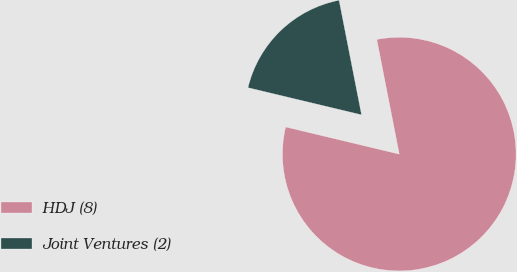Convert chart. <chart><loc_0><loc_0><loc_500><loc_500><pie_chart><fcel>HDJ (8)<fcel>Joint Ventures (2)<nl><fcel>81.82%<fcel>18.18%<nl></chart> 